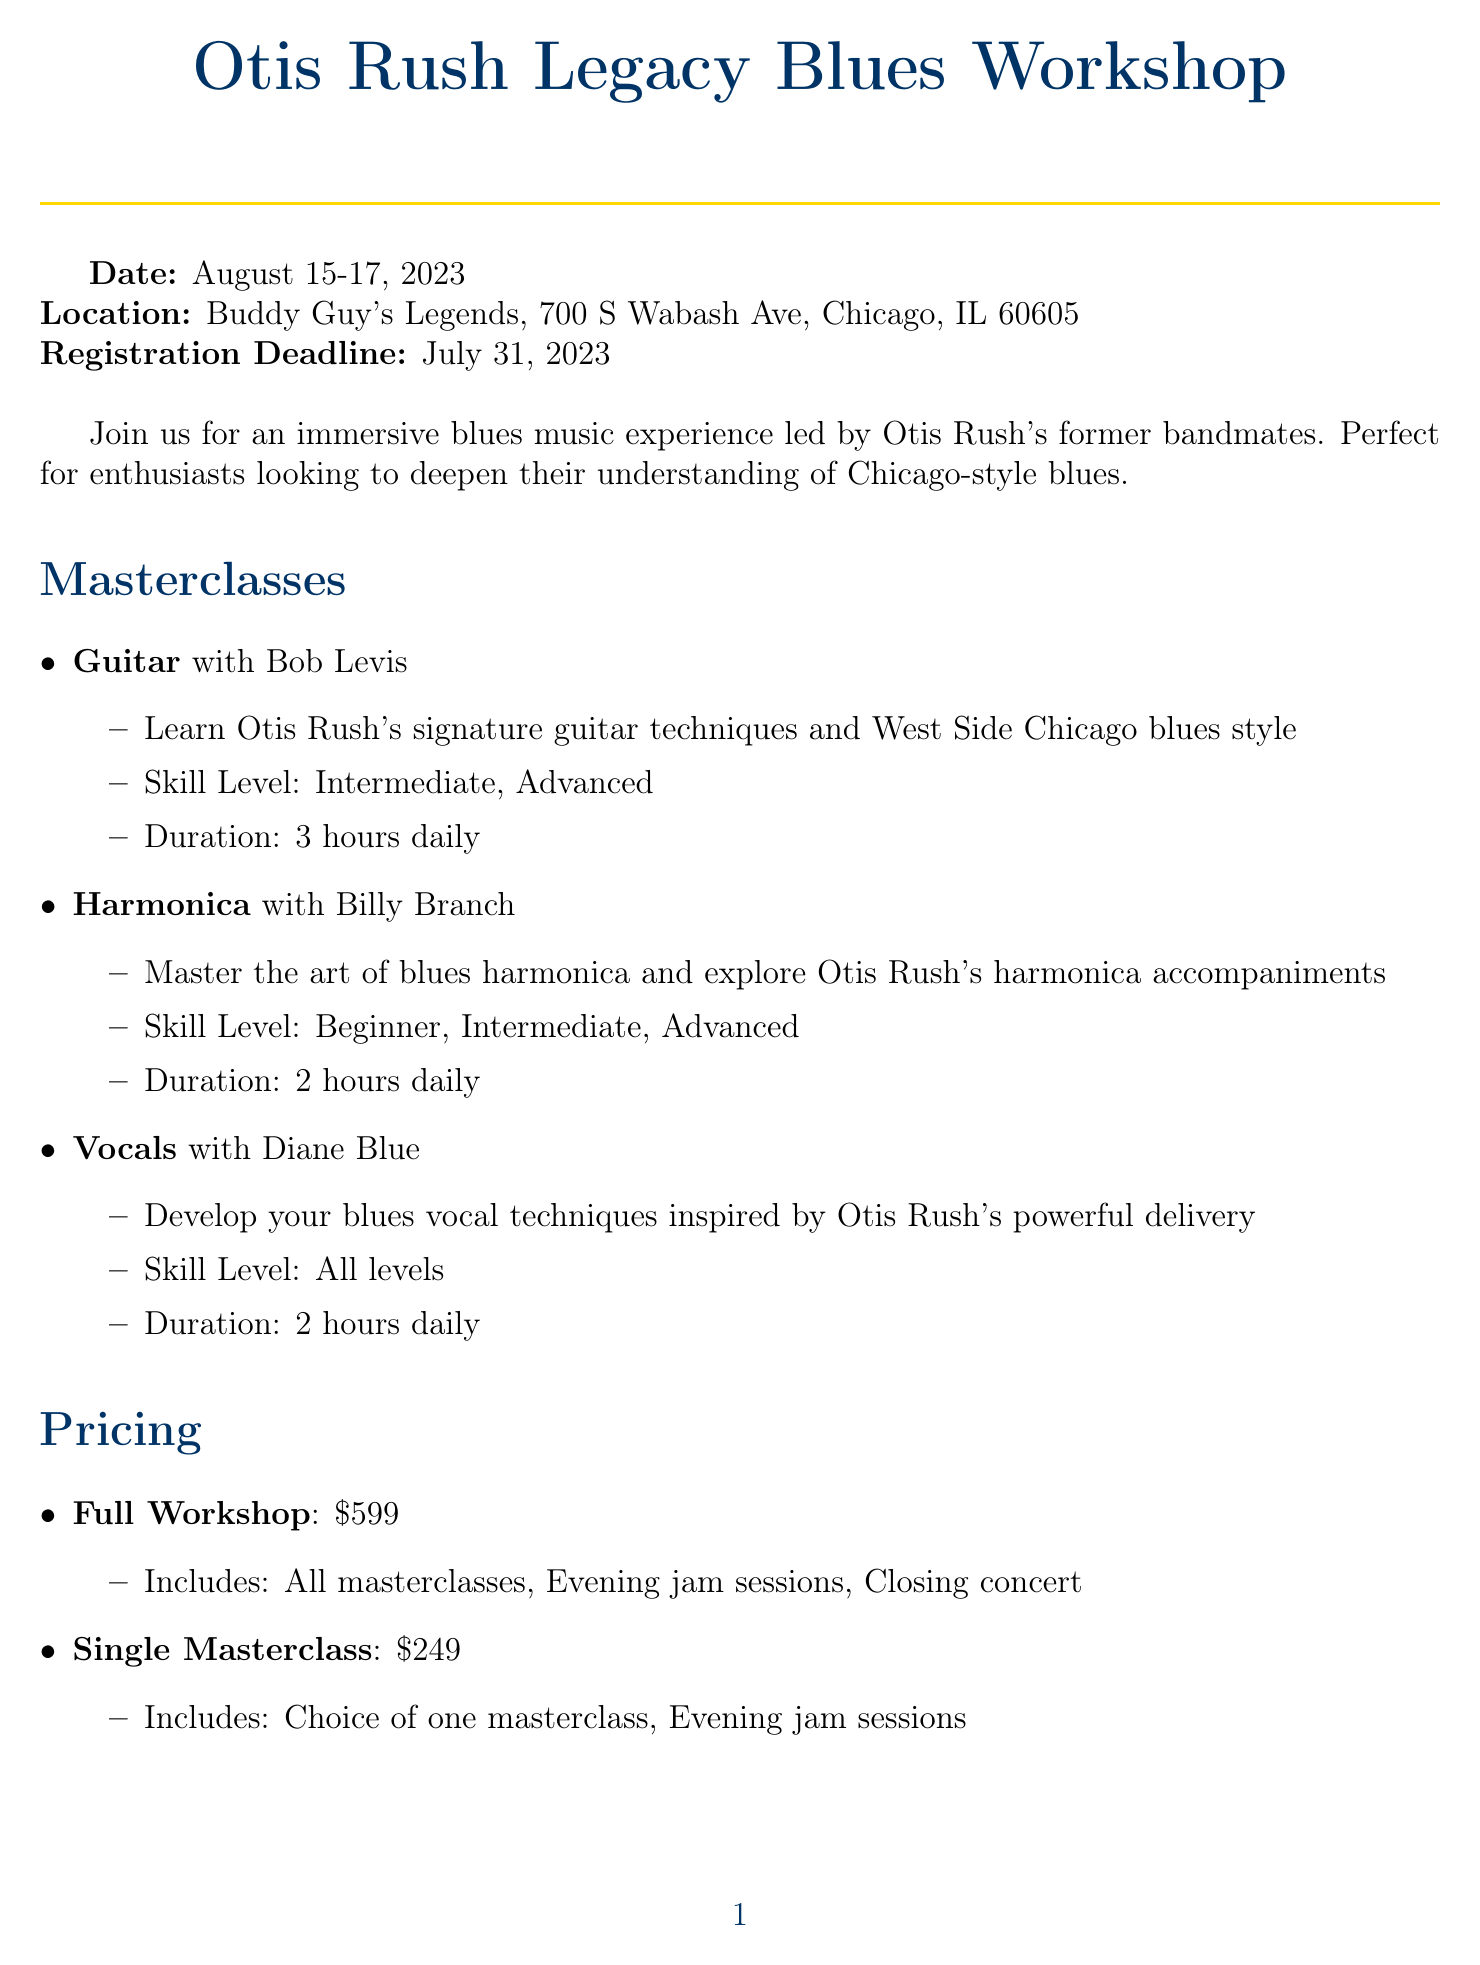What is the title of the workshop? The title of the workshop is stated at the top of the document.
Answer: Otis Rush Legacy Blues Workshop Who is the instructor for the Guitar masterclass? The instructor for the Guitar masterclass is mentioned in the masterclass section of the document.
Answer: Bob Levis What is the price for a Single Masterclass? The price for a Single Masterclass is listed under the pricing section of the document.
Answer: 249 What are the dates of the workshop? The dates of the workshop are specified early in the document.
Answer: August 15-17, 2023 What is the location of the workshop? The location is provided in the document as part of the event details.
Answer: Buddy Guy's Legends, 700 S Wabash Ave, Chicago, IL 60605 What skill levels are available for the Harmonica masterclass? The available skill levels for the Harmonica masterclass are listed in the document under the respective masterclass.
Answer: Beginner, Intermediate, Advanced What is the cancellation policy for the workshop? The cancellation policy is detailed in a specific section of the document.
Answer: Full refund available up to 14 days before the workshop How long is the Vocal masterclass conducted daily? The duration for the Vocal masterclass is mentioned in the masterclass description.
Answer: 2 hours daily What type of payment options are listed? The payment options are outlined in a dedicated section of the document.
Answer: Credit Card, PayPal, Bank Transfer 